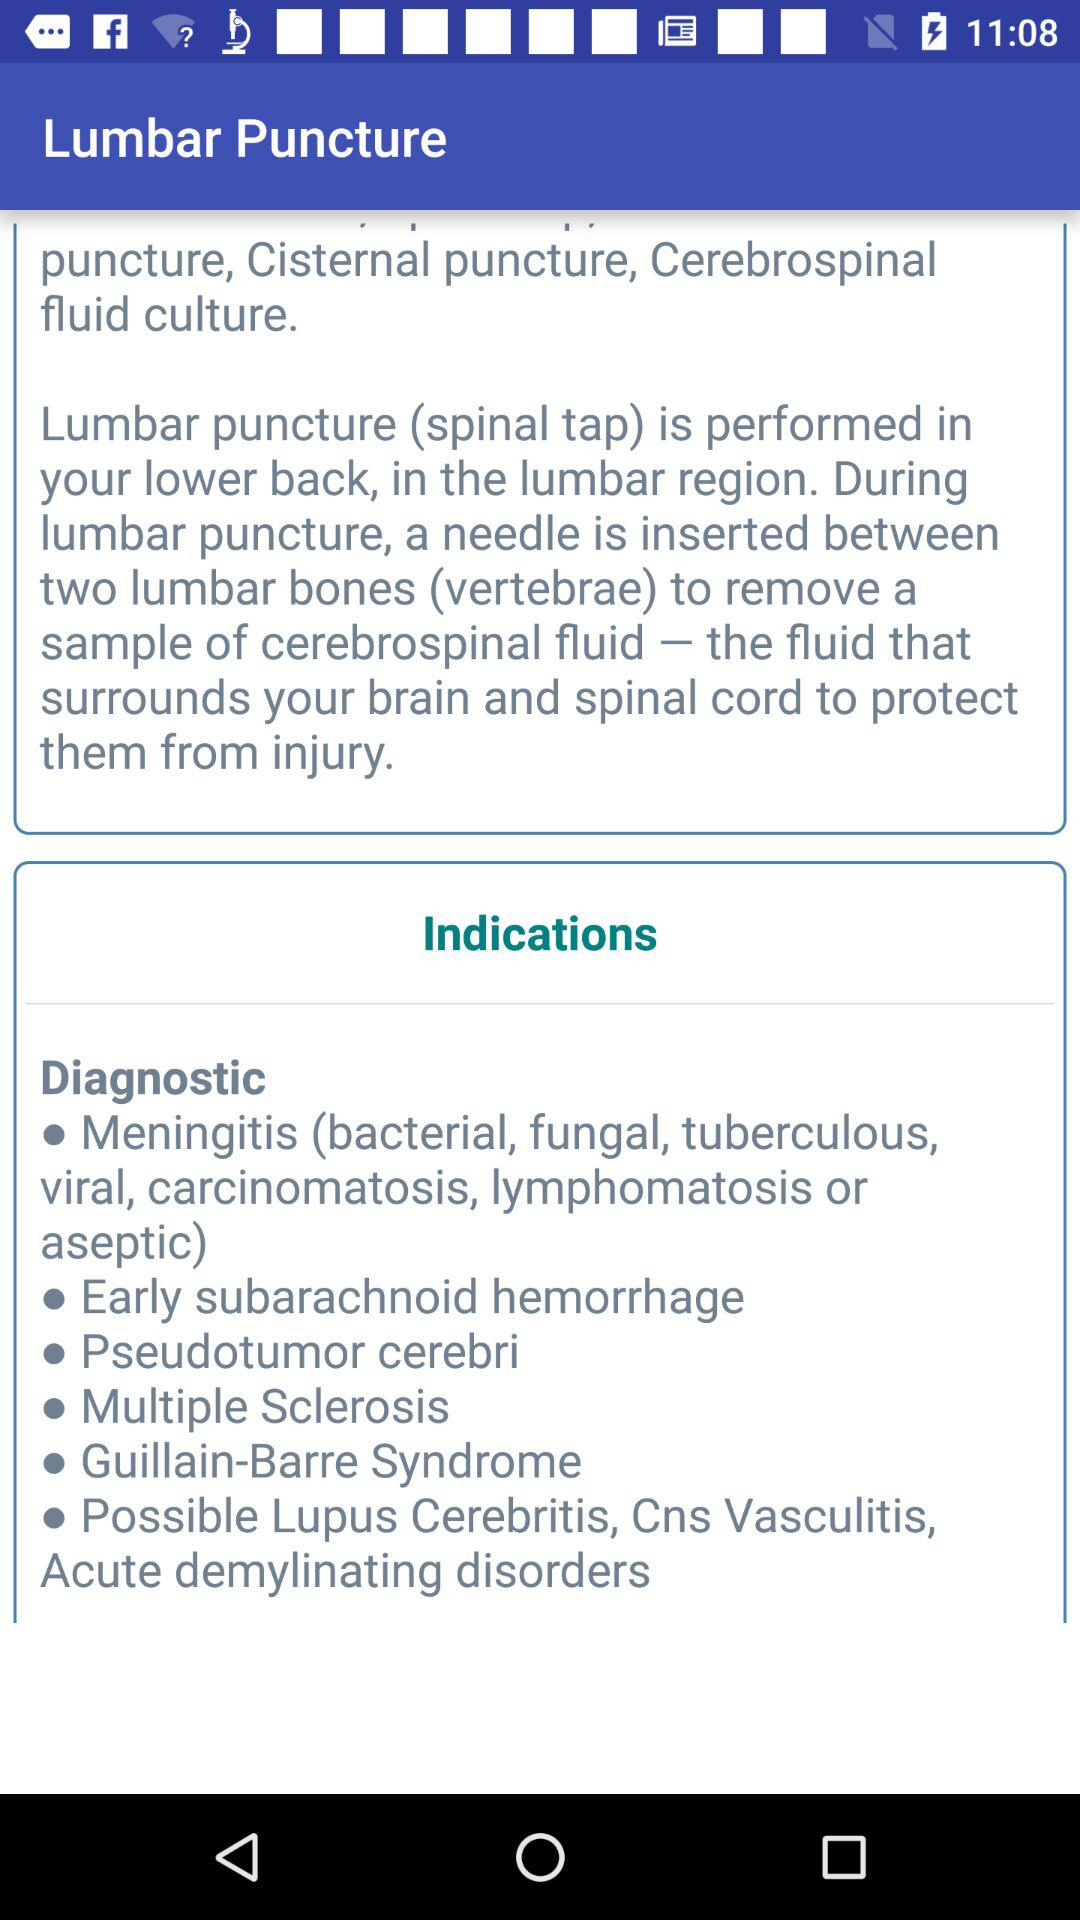On which part of the body is lumbar puncture performed? Lumbar puncture is performed in the lower back, in the lumbar region. 